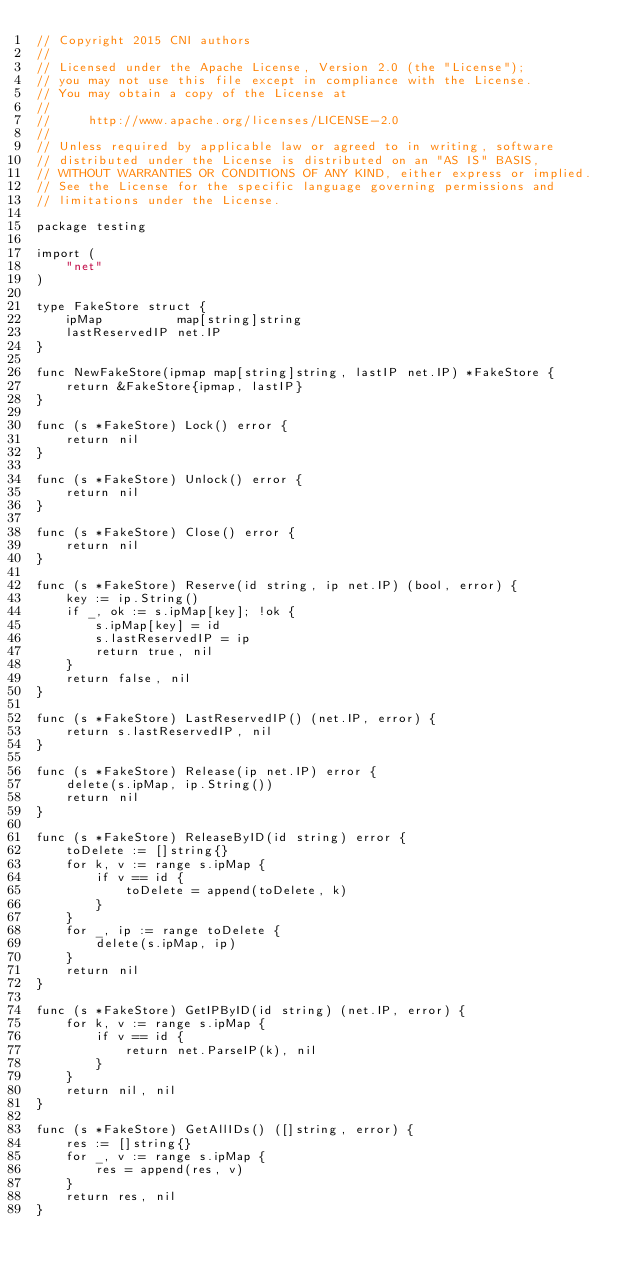<code> <loc_0><loc_0><loc_500><loc_500><_Go_>// Copyright 2015 CNI authors
//
// Licensed under the Apache License, Version 2.0 (the "License");
// you may not use this file except in compliance with the License.
// You may obtain a copy of the License at
//
//     http://www.apache.org/licenses/LICENSE-2.0
//
// Unless required by applicable law or agreed to in writing, software
// distributed under the License is distributed on an "AS IS" BASIS,
// WITHOUT WARRANTIES OR CONDITIONS OF ANY KIND, either express or implied.
// See the License for the specific language governing permissions and
// limitations under the License.

package testing

import (
	"net"
)

type FakeStore struct {
	ipMap          map[string]string
	lastReservedIP net.IP
}

func NewFakeStore(ipmap map[string]string, lastIP net.IP) *FakeStore {
	return &FakeStore{ipmap, lastIP}
}

func (s *FakeStore) Lock() error {
	return nil
}

func (s *FakeStore) Unlock() error {
	return nil
}

func (s *FakeStore) Close() error {
	return nil
}

func (s *FakeStore) Reserve(id string, ip net.IP) (bool, error) {
	key := ip.String()
	if _, ok := s.ipMap[key]; !ok {
		s.ipMap[key] = id
		s.lastReservedIP = ip
		return true, nil
	}
	return false, nil
}

func (s *FakeStore) LastReservedIP() (net.IP, error) {
	return s.lastReservedIP, nil
}

func (s *FakeStore) Release(ip net.IP) error {
	delete(s.ipMap, ip.String())
	return nil
}

func (s *FakeStore) ReleaseByID(id string) error {
	toDelete := []string{}
	for k, v := range s.ipMap {
		if v == id {
			toDelete = append(toDelete, k)
		}
	}
	for _, ip := range toDelete {
		delete(s.ipMap, ip)
	}
	return nil
}

func (s *FakeStore) GetIPByID(id string) (net.IP, error) {
	for k, v := range s.ipMap {
		if v == id {
			return net.ParseIP(k), nil
		}
	}
	return nil, nil
}

func (s *FakeStore) GetAllIDs() ([]string, error) {
	res := []string{}
	for _, v := range s.ipMap {
		res = append(res, v)
	}
	return res, nil
}
</code> 